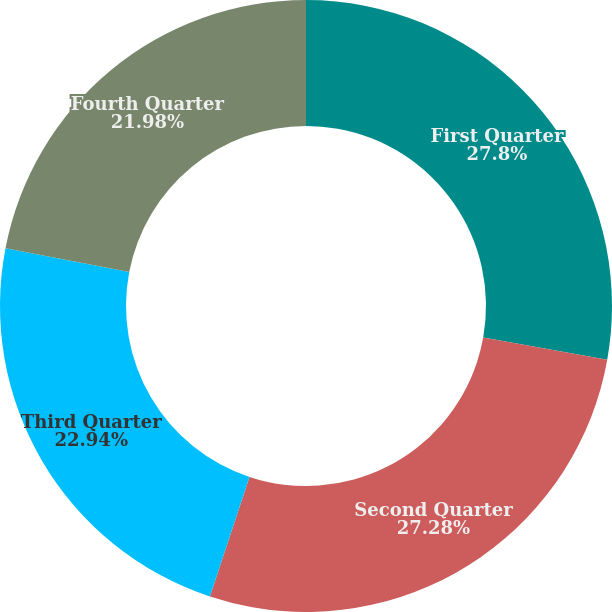<chart> <loc_0><loc_0><loc_500><loc_500><pie_chart><fcel>First Quarter<fcel>Second Quarter<fcel>Third Quarter<fcel>Fourth Quarter<nl><fcel>27.81%<fcel>27.28%<fcel>22.94%<fcel>21.98%<nl></chart> 